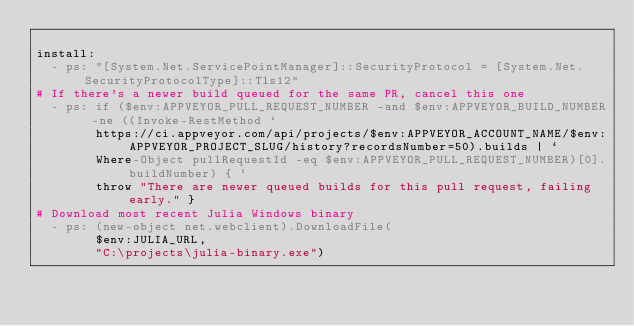Convert code to text. <code><loc_0><loc_0><loc_500><loc_500><_YAML_>
install:
  - ps: "[System.Net.ServicePointManager]::SecurityProtocol = [System.Net.SecurityProtocolType]::Tls12"
# If there's a newer build queued for the same PR, cancel this one
  - ps: if ($env:APPVEYOR_PULL_REQUEST_NUMBER -and $env:APPVEYOR_BUILD_NUMBER -ne ((Invoke-RestMethod `
        https://ci.appveyor.com/api/projects/$env:APPVEYOR_ACCOUNT_NAME/$env:APPVEYOR_PROJECT_SLUG/history?recordsNumber=50).builds | `
        Where-Object pullRequestId -eq $env:APPVEYOR_PULL_REQUEST_NUMBER)[0].buildNumber) { `
        throw "There are newer queued builds for this pull request, failing early." }
# Download most recent Julia Windows binary
  - ps: (new-object net.webclient).DownloadFile(
        $env:JULIA_URL,
        "C:\projects\julia-binary.exe")</code> 